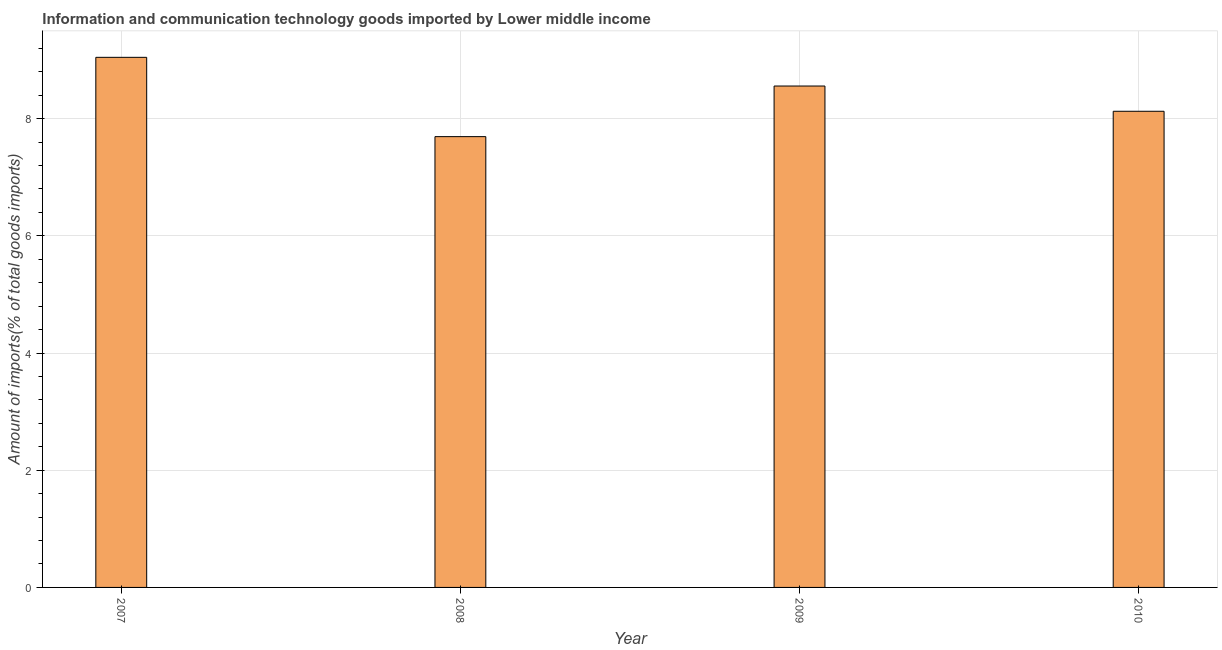Does the graph contain grids?
Your response must be concise. Yes. What is the title of the graph?
Your answer should be very brief. Information and communication technology goods imported by Lower middle income. What is the label or title of the X-axis?
Provide a short and direct response. Year. What is the label or title of the Y-axis?
Offer a very short reply. Amount of imports(% of total goods imports). What is the amount of ict goods imports in 2007?
Offer a terse response. 9.05. Across all years, what is the maximum amount of ict goods imports?
Offer a very short reply. 9.05. Across all years, what is the minimum amount of ict goods imports?
Keep it short and to the point. 7.69. In which year was the amount of ict goods imports maximum?
Your response must be concise. 2007. What is the sum of the amount of ict goods imports?
Offer a terse response. 33.42. What is the difference between the amount of ict goods imports in 2009 and 2010?
Give a very brief answer. 0.43. What is the average amount of ict goods imports per year?
Provide a short and direct response. 8.36. What is the median amount of ict goods imports?
Make the answer very short. 8.34. Do a majority of the years between 2008 and 2007 (inclusive) have amount of ict goods imports greater than 4 %?
Keep it short and to the point. No. What is the ratio of the amount of ict goods imports in 2007 to that in 2009?
Provide a short and direct response. 1.06. Is the difference between the amount of ict goods imports in 2007 and 2009 greater than the difference between any two years?
Your response must be concise. No. What is the difference between the highest and the second highest amount of ict goods imports?
Keep it short and to the point. 0.49. What is the difference between the highest and the lowest amount of ict goods imports?
Make the answer very short. 1.35. How many bars are there?
Provide a succinct answer. 4. How many years are there in the graph?
Make the answer very short. 4. What is the difference between two consecutive major ticks on the Y-axis?
Offer a very short reply. 2. What is the Amount of imports(% of total goods imports) of 2007?
Offer a very short reply. 9.05. What is the Amount of imports(% of total goods imports) of 2008?
Ensure brevity in your answer.  7.69. What is the Amount of imports(% of total goods imports) in 2009?
Provide a succinct answer. 8.56. What is the Amount of imports(% of total goods imports) of 2010?
Your answer should be very brief. 8.13. What is the difference between the Amount of imports(% of total goods imports) in 2007 and 2008?
Your answer should be very brief. 1.35. What is the difference between the Amount of imports(% of total goods imports) in 2007 and 2009?
Your response must be concise. 0.49. What is the difference between the Amount of imports(% of total goods imports) in 2007 and 2010?
Your response must be concise. 0.92. What is the difference between the Amount of imports(% of total goods imports) in 2008 and 2009?
Provide a short and direct response. -0.86. What is the difference between the Amount of imports(% of total goods imports) in 2008 and 2010?
Make the answer very short. -0.43. What is the difference between the Amount of imports(% of total goods imports) in 2009 and 2010?
Ensure brevity in your answer.  0.43. What is the ratio of the Amount of imports(% of total goods imports) in 2007 to that in 2008?
Your response must be concise. 1.18. What is the ratio of the Amount of imports(% of total goods imports) in 2007 to that in 2009?
Offer a terse response. 1.06. What is the ratio of the Amount of imports(% of total goods imports) in 2007 to that in 2010?
Keep it short and to the point. 1.11. What is the ratio of the Amount of imports(% of total goods imports) in 2008 to that in 2009?
Offer a terse response. 0.9. What is the ratio of the Amount of imports(% of total goods imports) in 2008 to that in 2010?
Give a very brief answer. 0.95. What is the ratio of the Amount of imports(% of total goods imports) in 2009 to that in 2010?
Keep it short and to the point. 1.05. 